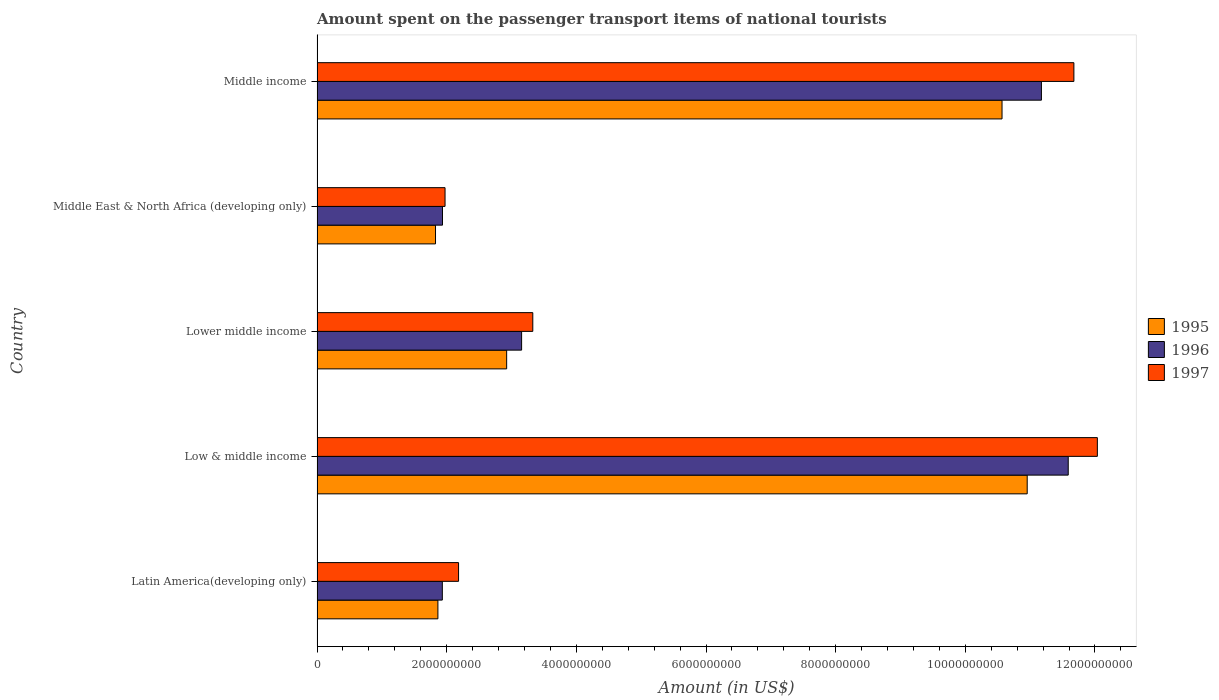Are the number of bars on each tick of the Y-axis equal?
Make the answer very short. Yes. What is the label of the 2nd group of bars from the top?
Your answer should be very brief. Middle East & North Africa (developing only). In how many cases, is the number of bars for a given country not equal to the number of legend labels?
Offer a very short reply. 0. What is the amount spent on the passenger transport items of national tourists in 1996 in Middle income?
Offer a very short reply. 1.12e+1. Across all countries, what is the maximum amount spent on the passenger transport items of national tourists in 1997?
Your answer should be compact. 1.20e+1. Across all countries, what is the minimum amount spent on the passenger transport items of national tourists in 1997?
Keep it short and to the point. 1.97e+09. In which country was the amount spent on the passenger transport items of national tourists in 1995 maximum?
Give a very brief answer. Low & middle income. In which country was the amount spent on the passenger transport items of national tourists in 1996 minimum?
Offer a very short reply. Latin America(developing only). What is the total amount spent on the passenger transport items of national tourists in 1995 in the graph?
Keep it short and to the point. 2.81e+1. What is the difference between the amount spent on the passenger transport items of national tourists in 1995 in Middle East & North Africa (developing only) and that in Middle income?
Make the answer very short. -8.74e+09. What is the difference between the amount spent on the passenger transport items of national tourists in 1996 in Middle East & North Africa (developing only) and the amount spent on the passenger transport items of national tourists in 1995 in Low & middle income?
Provide a succinct answer. -9.02e+09. What is the average amount spent on the passenger transport items of national tourists in 1997 per country?
Offer a very short reply. 6.24e+09. What is the difference between the amount spent on the passenger transport items of national tourists in 1995 and amount spent on the passenger transport items of national tourists in 1997 in Middle income?
Offer a very short reply. -1.11e+09. What is the ratio of the amount spent on the passenger transport items of national tourists in 1996 in Latin America(developing only) to that in Middle East & North Africa (developing only)?
Provide a succinct answer. 1. Is the amount spent on the passenger transport items of national tourists in 1996 in Middle East & North Africa (developing only) less than that in Middle income?
Offer a terse response. Yes. What is the difference between the highest and the second highest amount spent on the passenger transport items of national tourists in 1996?
Offer a very short reply. 4.14e+08. What is the difference between the highest and the lowest amount spent on the passenger transport items of national tourists in 1996?
Offer a terse response. 9.65e+09. What does the 3rd bar from the top in Lower middle income represents?
Give a very brief answer. 1995. What does the 2nd bar from the bottom in Low & middle income represents?
Your response must be concise. 1996. Is it the case that in every country, the sum of the amount spent on the passenger transport items of national tourists in 1996 and amount spent on the passenger transport items of national tourists in 1995 is greater than the amount spent on the passenger transport items of national tourists in 1997?
Offer a very short reply. Yes. How many bars are there?
Give a very brief answer. 15. How many countries are there in the graph?
Ensure brevity in your answer.  5. What is the difference between two consecutive major ticks on the X-axis?
Give a very brief answer. 2.00e+09. Does the graph contain grids?
Keep it short and to the point. No. What is the title of the graph?
Ensure brevity in your answer.  Amount spent on the passenger transport items of national tourists. Does "1998" appear as one of the legend labels in the graph?
Ensure brevity in your answer.  No. What is the label or title of the X-axis?
Give a very brief answer. Amount (in US$). What is the Amount (in US$) of 1995 in Latin America(developing only)?
Offer a very short reply. 1.86e+09. What is the Amount (in US$) of 1996 in Latin America(developing only)?
Provide a succinct answer. 1.93e+09. What is the Amount (in US$) of 1997 in Latin America(developing only)?
Provide a short and direct response. 2.18e+09. What is the Amount (in US$) of 1995 in Low & middle income?
Keep it short and to the point. 1.10e+1. What is the Amount (in US$) in 1996 in Low & middle income?
Provide a short and direct response. 1.16e+1. What is the Amount (in US$) in 1997 in Low & middle income?
Ensure brevity in your answer.  1.20e+1. What is the Amount (in US$) of 1995 in Lower middle income?
Provide a succinct answer. 2.92e+09. What is the Amount (in US$) in 1996 in Lower middle income?
Offer a terse response. 3.16e+09. What is the Amount (in US$) in 1997 in Lower middle income?
Give a very brief answer. 3.33e+09. What is the Amount (in US$) in 1995 in Middle East & North Africa (developing only)?
Offer a very short reply. 1.83e+09. What is the Amount (in US$) in 1996 in Middle East & North Africa (developing only)?
Your answer should be compact. 1.94e+09. What is the Amount (in US$) of 1997 in Middle East & North Africa (developing only)?
Keep it short and to the point. 1.97e+09. What is the Amount (in US$) in 1995 in Middle income?
Provide a short and direct response. 1.06e+1. What is the Amount (in US$) of 1996 in Middle income?
Offer a terse response. 1.12e+1. What is the Amount (in US$) in 1997 in Middle income?
Keep it short and to the point. 1.17e+1. Across all countries, what is the maximum Amount (in US$) in 1995?
Offer a terse response. 1.10e+1. Across all countries, what is the maximum Amount (in US$) in 1996?
Keep it short and to the point. 1.16e+1. Across all countries, what is the maximum Amount (in US$) in 1997?
Your answer should be compact. 1.20e+1. Across all countries, what is the minimum Amount (in US$) of 1995?
Provide a succinct answer. 1.83e+09. Across all countries, what is the minimum Amount (in US$) in 1996?
Your answer should be very brief. 1.93e+09. Across all countries, what is the minimum Amount (in US$) of 1997?
Offer a very short reply. 1.97e+09. What is the total Amount (in US$) in 1995 in the graph?
Provide a short and direct response. 2.81e+1. What is the total Amount (in US$) of 1996 in the graph?
Your answer should be very brief. 2.98e+1. What is the total Amount (in US$) in 1997 in the graph?
Ensure brevity in your answer.  3.12e+1. What is the difference between the Amount (in US$) of 1995 in Latin America(developing only) and that in Low & middle income?
Your answer should be very brief. -9.09e+09. What is the difference between the Amount (in US$) of 1996 in Latin America(developing only) and that in Low & middle income?
Provide a succinct answer. -9.65e+09. What is the difference between the Amount (in US$) in 1997 in Latin America(developing only) and that in Low & middle income?
Keep it short and to the point. -9.85e+09. What is the difference between the Amount (in US$) in 1995 in Latin America(developing only) and that in Lower middle income?
Offer a terse response. -1.06e+09. What is the difference between the Amount (in US$) in 1996 in Latin America(developing only) and that in Lower middle income?
Provide a short and direct response. -1.22e+09. What is the difference between the Amount (in US$) of 1997 in Latin America(developing only) and that in Lower middle income?
Give a very brief answer. -1.15e+09. What is the difference between the Amount (in US$) in 1995 in Latin America(developing only) and that in Middle East & North Africa (developing only)?
Offer a very short reply. 3.68e+07. What is the difference between the Amount (in US$) in 1996 in Latin America(developing only) and that in Middle East & North Africa (developing only)?
Your answer should be compact. -2.54e+06. What is the difference between the Amount (in US$) of 1997 in Latin America(developing only) and that in Middle East & North Africa (developing only)?
Your answer should be very brief. 2.09e+08. What is the difference between the Amount (in US$) of 1995 in Latin America(developing only) and that in Middle income?
Provide a short and direct response. -8.70e+09. What is the difference between the Amount (in US$) in 1996 in Latin America(developing only) and that in Middle income?
Offer a very short reply. -9.24e+09. What is the difference between the Amount (in US$) of 1997 in Latin America(developing only) and that in Middle income?
Make the answer very short. -9.49e+09. What is the difference between the Amount (in US$) of 1995 in Low & middle income and that in Lower middle income?
Make the answer very short. 8.03e+09. What is the difference between the Amount (in US$) in 1996 in Low & middle income and that in Lower middle income?
Provide a short and direct response. 8.43e+09. What is the difference between the Amount (in US$) in 1997 in Low & middle income and that in Lower middle income?
Give a very brief answer. 8.71e+09. What is the difference between the Amount (in US$) in 1995 in Low & middle income and that in Middle East & North Africa (developing only)?
Provide a succinct answer. 9.13e+09. What is the difference between the Amount (in US$) of 1996 in Low & middle income and that in Middle East & North Africa (developing only)?
Keep it short and to the point. 9.65e+09. What is the difference between the Amount (in US$) in 1997 in Low & middle income and that in Middle East & North Africa (developing only)?
Provide a succinct answer. 1.01e+1. What is the difference between the Amount (in US$) in 1995 in Low & middle income and that in Middle income?
Ensure brevity in your answer.  3.88e+08. What is the difference between the Amount (in US$) in 1996 in Low & middle income and that in Middle income?
Make the answer very short. 4.14e+08. What is the difference between the Amount (in US$) in 1997 in Low & middle income and that in Middle income?
Keep it short and to the point. 3.62e+08. What is the difference between the Amount (in US$) in 1995 in Lower middle income and that in Middle East & North Africa (developing only)?
Offer a terse response. 1.10e+09. What is the difference between the Amount (in US$) in 1996 in Lower middle income and that in Middle East & North Africa (developing only)?
Provide a succinct answer. 1.22e+09. What is the difference between the Amount (in US$) of 1997 in Lower middle income and that in Middle East & North Africa (developing only)?
Provide a short and direct response. 1.35e+09. What is the difference between the Amount (in US$) in 1995 in Lower middle income and that in Middle income?
Keep it short and to the point. -7.64e+09. What is the difference between the Amount (in US$) of 1996 in Lower middle income and that in Middle income?
Your response must be concise. -8.02e+09. What is the difference between the Amount (in US$) in 1997 in Lower middle income and that in Middle income?
Provide a short and direct response. -8.35e+09. What is the difference between the Amount (in US$) of 1995 in Middle East & North Africa (developing only) and that in Middle income?
Provide a short and direct response. -8.74e+09. What is the difference between the Amount (in US$) in 1996 in Middle East & North Africa (developing only) and that in Middle income?
Provide a short and direct response. -9.24e+09. What is the difference between the Amount (in US$) in 1997 in Middle East & North Africa (developing only) and that in Middle income?
Ensure brevity in your answer.  -9.70e+09. What is the difference between the Amount (in US$) in 1995 in Latin America(developing only) and the Amount (in US$) in 1996 in Low & middle income?
Keep it short and to the point. -9.72e+09. What is the difference between the Amount (in US$) in 1995 in Latin America(developing only) and the Amount (in US$) in 1997 in Low & middle income?
Make the answer very short. -1.02e+1. What is the difference between the Amount (in US$) in 1996 in Latin America(developing only) and the Amount (in US$) in 1997 in Low & middle income?
Give a very brief answer. -1.01e+1. What is the difference between the Amount (in US$) in 1995 in Latin America(developing only) and the Amount (in US$) in 1996 in Lower middle income?
Give a very brief answer. -1.29e+09. What is the difference between the Amount (in US$) of 1995 in Latin America(developing only) and the Amount (in US$) of 1997 in Lower middle income?
Offer a very short reply. -1.46e+09. What is the difference between the Amount (in US$) of 1996 in Latin America(developing only) and the Amount (in US$) of 1997 in Lower middle income?
Provide a short and direct response. -1.40e+09. What is the difference between the Amount (in US$) in 1995 in Latin America(developing only) and the Amount (in US$) in 1996 in Middle East & North Africa (developing only)?
Ensure brevity in your answer.  -7.09e+07. What is the difference between the Amount (in US$) of 1995 in Latin America(developing only) and the Amount (in US$) of 1997 in Middle East & North Africa (developing only)?
Provide a succinct answer. -1.10e+08. What is the difference between the Amount (in US$) in 1996 in Latin America(developing only) and the Amount (in US$) in 1997 in Middle East & North Africa (developing only)?
Make the answer very short. -4.17e+07. What is the difference between the Amount (in US$) of 1995 in Latin America(developing only) and the Amount (in US$) of 1996 in Middle income?
Your response must be concise. -9.31e+09. What is the difference between the Amount (in US$) of 1995 in Latin America(developing only) and the Amount (in US$) of 1997 in Middle income?
Ensure brevity in your answer.  -9.81e+09. What is the difference between the Amount (in US$) in 1996 in Latin America(developing only) and the Amount (in US$) in 1997 in Middle income?
Your response must be concise. -9.74e+09. What is the difference between the Amount (in US$) of 1995 in Low & middle income and the Amount (in US$) of 1996 in Lower middle income?
Provide a short and direct response. 7.80e+09. What is the difference between the Amount (in US$) in 1995 in Low & middle income and the Amount (in US$) in 1997 in Lower middle income?
Offer a very short reply. 7.63e+09. What is the difference between the Amount (in US$) in 1996 in Low & middle income and the Amount (in US$) in 1997 in Lower middle income?
Ensure brevity in your answer.  8.26e+09. What is the difference between the Amount (in US$) in 1995 in Low & middle income and the Amount (in US$) in 1996 in Middle East & North Africa (developing only)?
Make the answer very short. 9.02e+09. What is the difference between the Amount (in US$) in 1995 in Low & middle income and the Amount (in US$) in 1997 in Middle East & North Africa (developing only)?
Your response must be concise. 8.98e+09. What is the difference between the Amount (in US$) in 1996 in Low & middle income and the Amount (in US$) in 1997 in Middle East & North Africa (developing only)?
Provide a short and direct response. 9.61e+09. What is the difference between the Amount (in US$) in 1995 in Low & middle income and the Amount (in US$) in 1996 in Middle income?
Offer a very short reply. -2.19e+08. What is the difference between the Amount (in US$) in 1995 in Low & middle income and the Amount (in US$) in 1997 in Middle income?
Give a very brief answer. -7.20e+08. What is the difference between the Amount (in US$) of 1996 in Low & middle income and the Amount (in US$) of 1997 in Middle income?
Provide a short and direct response. -8.74e+07. What is the difference between the Amount (in US$) in 1995 in Lower middle income and the Amount (in US$) in 1996 in Middle East & North Africa (developing only)?
Offer a terse response. 9.90e+08. What is the difference between the Amount (in US$) in 1995 in Lower middle income and the Amount (in US$) in 1997 in Middle East & North Africa (developing only)?
Ensure brevity in your answer.  9.50e+08. What is the difference between the Amount (in US$) in 1996 in Lower middle income and the Amount (in US$) in 1997 in Middle East & North Africa (developing only)?
Give a very brief answer. 1.18e+09. What is the difference between the Amount (in US$) of 1995 in Lower middle income and the Amount (in US$) of 1996 in Middle income?
Ensure brevity in your answer.  -8.25e+09. What is the difference between the Amount (in US$) of 1995 in Lower middle income and the Amount (in US$) of 1997 in Middle income?
Give a very brief answer. -8.75e+09. What is the difference between the Amount (in US$) of 1996 in Lower middle income and the Amount (in US$) of 1997 in Middle income?
Provide a succinct answer. -8.52e+09. What is the difference between the Amount (in US$) in 1995 in Middle East & North Africa (developing only) and the Amount (in US$) in 1996 in Middle income?
Provide a short and direct response. -9.35e+09. What is the difference between the Amount (in US$) of 1995 in Middle East & North Africa (developing only) and the Amount (in US$) of 1997 in Middle income?
Your answer should be very brief. -9.85e+09. What is the difference between the Amount (in US$) in 1996 in Middle East & North Africa (developing only) and the Amount (in US$) in 1997 in Middle income?
Keep it short and to the point. -9.74e+09. What is the average Amount (in US$) of 1995 per country?
Provide a short and direct response. 5.63e+09. What is the average Amount (in US$) in 1996 per country?
Offer a very short reply. 5.96e+09. What is the average Amount (in US$) in 1997 per country?
Make the answer very short. 6.24e+09. What is the difference between the Amount (in US$) in 1995 and Amount (in US$) in 1996 in Latin America(developing only)?
Your answer should be compact. -6.84e+07. What is the difference between the Amount (in US$) in 1995 and Amount (in US$) in 1997 in Latin America(developing only)?
Your response must be concise. -3.19e+08. What is the difference between the Amount (in US$) in 1996 and Amount (in US$) in 1997 in Latin America(developing only)?
Ensure brevity in your answer.  -2.50e+08. What is the difference between the Amount (in US$) in 1995 and Amount (in US$) in 1996 in Low & middle income?
Offer a very short reply. -6.33e+08. What is the difference between the Amount (in US$) in 1995 and Amount (in US$) in 1997 in Low & middle income?
Give a very brief answer. -1.08e+09. What is the difference between the Amount (in US$) of 1996 and Amount (in US$) of 1997 in Low & middle income?
Offer a terse response. -4.49e+08. What is the difference between the Amount (in US$) of 1995 and Amount (in US$) of 1996 in Lower middle income?
Offer a very short reply. -2.31e+08. What is the difference between the Amount (in US$) of 1995 and Amount (in US$) of 1997 in Lower middle income?
Provide a succinct answer. -4.03e+08. What is the difference between the Amount (in US$) of 1996 and Amount (in US$) of 1997 in Lower middle income?
Your answer should be compact. -1.73e+08. What is the difference between the Amount (in US$) of 1995 and Amount (in US$) of 1996 in Middle East & North Africa (developing only)?
Offer a terse response. -1.08e+08. What is the difference between the Amount (in US$) of 1995 and Amount (in US$) of 1997 in Middle East & North Africa (developing only)?
Give a very brief answer. -1.47e+08. What is the difference between the Amount (in US$) in 1996 and Amount (in US$) in 1997 in Middle East & North Africa (developing only)?
Provide a short and direct response. -3.92e+07. What is the difference between the Amount (in US$) of 1995 and Amount (in US$) of 1996 in Middle income?
Provide a succinct answer. -6.08e+08. What is the difference between the Amount (in US$) in 1995 and Amount (in US$) in 1997 in Middle income?
Provide a succinct answer. -1.11e+09. What is the difference between the Amount (in US$) of 1996 and Amount (in US$) of 1997 in Middle income?
Your response must be concise. -5.01e+08. What is the ratio of the Amount (in US$) of 1995 in Latin America(developing only) to that in Low & middle income?
Provide a succinct answer. 0.17. What is the ratio of the Amount (in US$) of 1996 in Latin America(developing only) to that in Low & middle income?
Provide a short and direct response. 0.17. What is the ratio of the Amount (in US$) of 1997 in Latin America(developing only) to that in Low & middle income?
Ensure brevity in your answer.  0.18. What is the ratio of the Amount (in US$) in 1995 in Latin America(developing only) to that in Lower middle income?
Provide a short and direct response. 0.64. What is the ratio of the Amount (in US$) of 1996 in Latin America(developing only) to that in Lower middle income?
Offer a terse response. 0.61. What is the ratio of the Amount (in US$) of 1997 in Latin America(developing only) to that in Lower middle income?
Keep it short and to the point. 0.66. What is the ratio of the Amount (in US$) of 1995 in Latin America(developing only) to that in Middle East & North Africa (developing only)?
Make the answer very short. 1.02. What is the ratio of the Amount (in US$) of 1997 in Latin America(developing only) to that in Middle East & North Africa (developing only)?
Provide a short and direct response. 1.11. What is the ratio of the Amount (in US$) of 1995 in Latin America(developing only) to that in Middle income?
Provide a short and direct response. 0.18. What is the ratio of the Amount (in US$) of 1996 in Latin America(developing only) to that in Middle income?
Your answer should be very brief. 0.17. What is the ratio of the Amount (in US$) in 1997 in Latin America(developing only) to that in Middle income?
Your answer should be very brief. 0.19. What is the ratio of the Amount (in US$) of 1995 in Low & middle income to that in Lower middle income?
Make the answer very short. 3.75. What is the ratio of the Amount (in US$) of 1996 in Low & middle income to that in Lower middle income?
Your answer should be compact. 3.67. What is the ratio of the Amount (in US$) in 1997 in Low & middle income to that in Lower middle income?
Keep it short and to the point. 3.62. What is the ratio of the Amount (in US$) of 1995 in Low & middle income to that in Middle East & North Africa (developing only)?
Your answer should be compact. 5.99. What is the ratio of the Amount (in US$) of 1996 in Low & middle income to that in Middle East & North Africa (developing only)?
Make the answer very short. 5.99. What is the ratio of the Amount (in US$) in 1997 in Low & middle income to that in Middle East & North Africa (developing only)?
Keep it short and to the point. 6.1. What is the ratio of the Amount (in US$) of 1995 in Low & middle income to that in Middle income?
Your response must be concise. 1.04. What is the ratio of the Amount (in US$) of 1997 in Low & middle income to that in Middle income?
Offer a very short reply. 1.03. What is the ratio of the Amount (in US$) of 1995 in Lower middle income to that in Middle East & North Africa (developing only)?
Ensure brevity in your answer.  1.6. What is the ratio of the Amount (in US$) of 1996 in Lower middle income to that in Middle East & North Africa (developing only)?
Your answer should be compact. 1.63. What is the ratio of the Amount (in US$) of 1997 in Lower middle income to that in Middle East & North Africa (developing only)?
Keep it short and to the point. 1.69. What is the ratio of the Amount (in US$) of 1995 in Lower middle income to that in Middle income?
Give a very brief answer. 0.28. What is the ratio of the Amount (in US$) in 1996 in Lower middle income to that in Middle income?
Give a very brief answer. 0.28. What is the ratio of the Amount (in US$) of 1997 in Lower middle income to that in Middle income?
Offer a terse response. 0.29. What is the ratio of the Amount (in US$) in 1995 in Middle East & North Africa (developing only) to that in Middle income?
Offer a terse response. 0.17. What is the ratio of the Amount (in US$) in 1996 in Middle East & North Africa (developing only) to that in Middle income?
Offer a very short reply. 0.17. What is the ratio of the Amount (in US$) in 1997 in Middle East & North Africa (developing only) to that in Middle income?
Make the answer very short. 0.17. What is the difference between the highest and the second highest Amount (in US$) in 1995?
Keep it short and to the point. 3.88e+08. What is the difference between the highest and the second highest Amount (in US$) of 1996?
Offer a very short reply. 4.14e+08. What is the difference between the highest and the second highest Amount (in US$) in 1997?
Your answer should be compact. 3.62e+08. What is the difference between the highest and the lowest Amount (in US$) of 1995?
Provide a succinct answer. 9.13e+09. What is the difference between the highest and the lowest Amount (in US$) in 1996?
Provide a short and direct response. 9.65e+09. What is the difference between the highest and the lowest Amount (in US$) in 1997?
Offer a very short reply. 1.01e+1. 